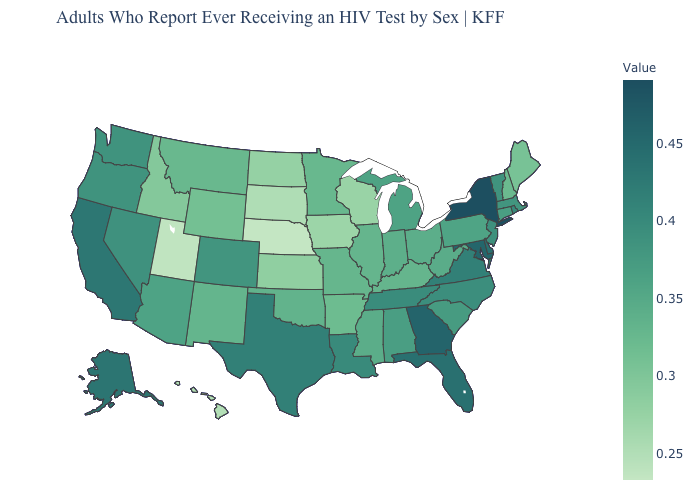Which states have the lowest value in the South?
Give a very brief answer. Arkansas. Which states hav the highest value in the South?
Concise answer only. Georgia. Which states hav the highest value in the West?
Answer briefly. Alaska. Does Tennessee have the highest value in the USA?
Give a very brief answer. No. Does the map have missing data?
Give a very brief answer. No. Does Nebraska have the lowest value in the USA?
Answer briefly. Yes. Among the states that border Connecticut , does New York have the lowest value?
Quick response, please. No. Which states have the lowest value in the South?
Be succinct. Arkansas. 